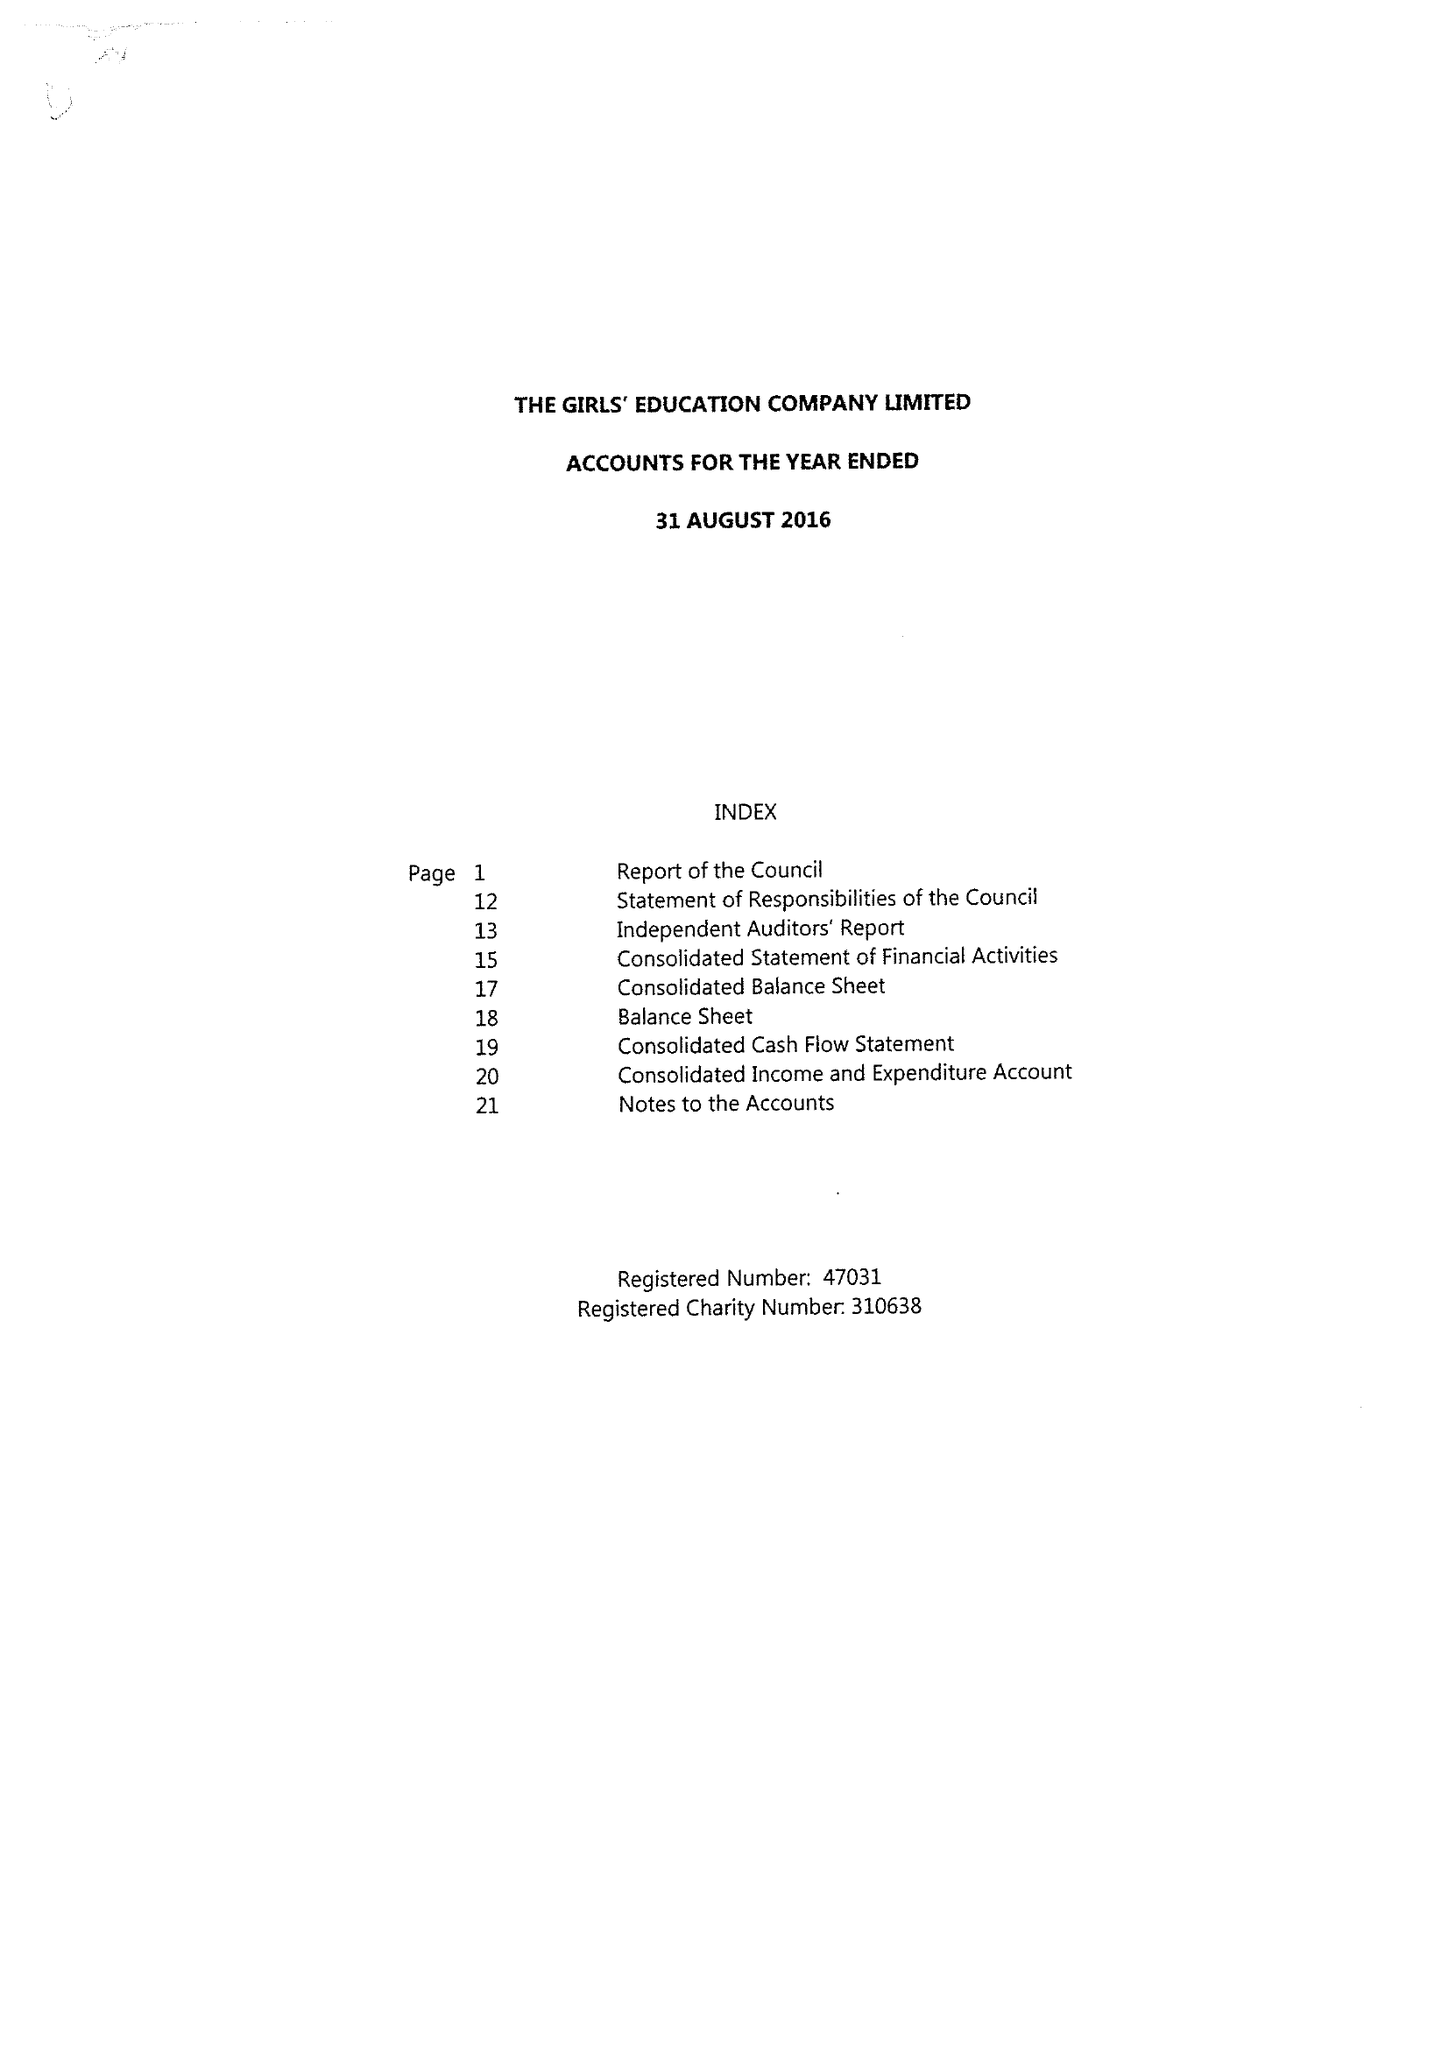What is the value for the income_annually_in_british_pounds?
Answer the question using a single word or phrase. 23367330.00 